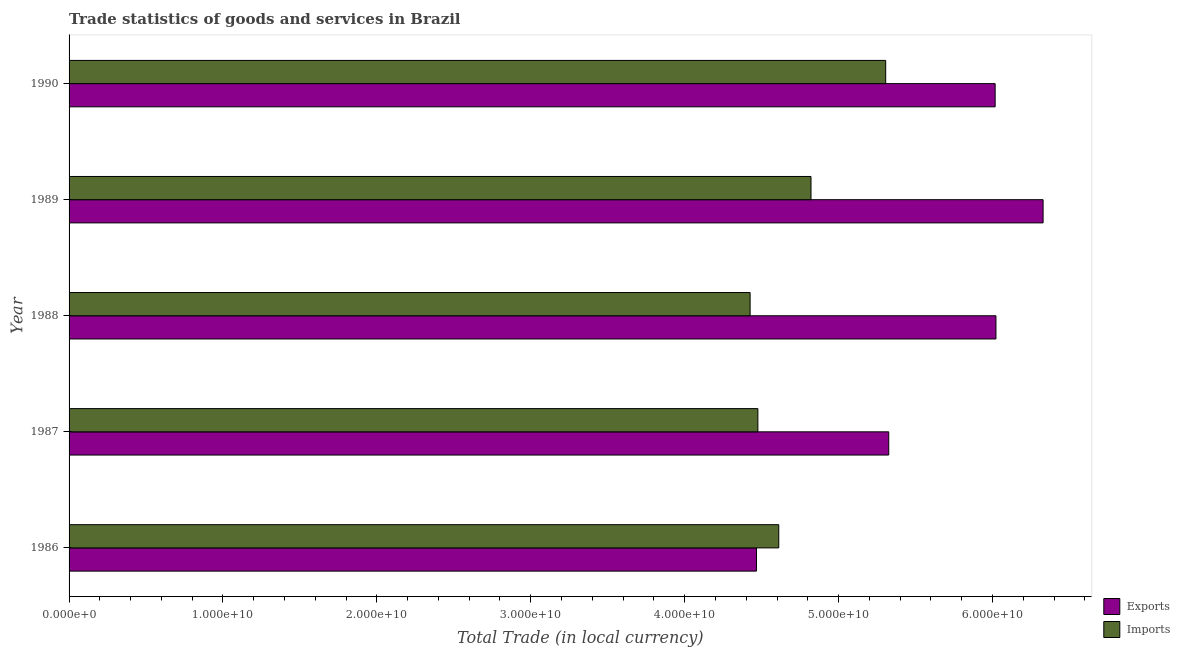How many different coloured bars are there?
Provide a succinct answer. 2. How many groups of bars are there?
Your answer should be very brief. 5. Are the number of bars per tick equal to the number of legend labels?
Provide a succinct answer. Yes. Are the number of bars on each tick of the Y-axis equal?
Give a very brief answer. Yes. What is the label of the 1st group of bars from the top?
Keep it short and to the point. 1990. What is the imports of goods and services in 1989?
Ensure brevity in your answer.  4.82e+1. Across all years, what is the maximum imports of goods and services?
Your response must be concise. 5.31e+1. Across all years, what is the minimum imports of goods and services?
Your answer should be compact. 4.43e+1. In which year was the export of goods and services maximum?
Keep it short and to the point. 1989. What is the total imports of goods and services in the graph?
Provide a short and direct response. 2.36e+11. What is the difference between the imports of goods and services in 1987 and that in 1988?
Provide a short and direct response. 5.04e+08. What is the difference between the imports of goods and services in 1989 and the export of goods and services in 1988?
Provide a short and direct response. -1.20e+1. What is the average imports of goods and services per year?
Ensure brevity in your answer.  4.73e+1. In the year 1987, what is the difference between the export of goods and services and imports of goods and services?
Offer a very short reply. 8.50e+09. In how many years, is the imports of goods and services greater than 48000000000 LCU?
Your answer should be compact. 2. What is the ratio of the imports of goods and services in 1986 to that in 1990?
Your answer should be very brief. 0.87. Is the imports of goods and services in 1986 less than that in 1988?
Keep it short and to the point. No. Is the difference between the imports of goods and services in 1986 and 1990 greater than the difference between the export of goods and services in 1986 and 1990?
Your answer should be very brief. Yes. What is the difference between the highest and the second highest imports of goods and services?
Your answer should be compact. 4.85e+09. What is the difference between the highest and the lowest imports of goods and services?
Your answer should be very brief. 8.81e+09. In how many years, is the export of goods and services greater than the average export of goods and services taken over all years?
Offer a very short reply. 3. Is the sum of the export of goods and services in 1988 and 1989 greater than the maximum imports of goods and services across all years?
Your answer should be compact. Yes. What does the 1st bar from the top in 1988 represents?
Your answer should be compact. Imports. What does the 1st bar from the bottom in 1987 represents?
Give a very brief answer. Exports. Are all the bars in the graph horizontal?
Offer a very short reply. Yes. What is the difference between two consecutive major ticks on the X-axis?
Give a very brief answer. 1.00e+1. Does the graph contain grids?
Provide a short and direct response. No. Where does the legend appear in the graph?
Your response must be concise. Bottom right. How many legend labels are there?
Ensure brevity in your answer.  2. What is the title of the graph?
Give a very brief answer. Trade statistics of goods and services in Brazil. What is the label or title of the X-axis?
Offer a very short reply. Total Trade (in local currency). What is the Total Trade (in local currency) of Exports in 1986?
Keep it short and to the point. 4.47e+1. What is the Total Trade (in local currency) in Imports in 1986?
Provide a succinct answer. 4.61e+1. What is the Total Trade (in local currency) of Exports in 1987?
Provide a succinct answer. 5.33e+1. What is the Total Trade (in local currency) in Imports in 1987?
Give a very brief answer. 4.48e+1. What is the Total Trade (in local currency) of Exports in 1988?
Offer a terse response. 6.02e+1. What is the Total Trade (in local currency) in Imports in 1988?
Your answer should be very brief. 4.43e+1. What is the Total Trade (in local currency) in Exports in 1989?
Your answer should be compact. 6.33e+1. What is the Total Trade (in local currency) of Imports in 1989?
Keep it short and to the point. 4.82e+1. What is the Total Trade (in local currency) in Exports in 1990?
Your answer should be compact. 6.02e+1. What is the Total Trade (in local currency) in Imports in 1990?
Give a very brief answer. 5.31e+1. Across all years, what is the maximum Total Trade (in local currency) of Exports?
Ensure brevity in your answer.  6.33e+1. Across all years, what is the maximum Total Trade (in local currency) of Imports?
Provide a succinct answer. 5.31e+1. Across all years, what is the minimum Total Trade (in local currency) in Exports?
Your answer should be compact. 4.47e+1. Across all years, what is the minimum Total Trade (in local currency) of Imports?
Provide a succinct answer. 4.43e+1. What is the total Total Trade (in local currency) of Exports in the graph?
Offer a terse response. 2.82e+11. What is the total Total Trade (in local currency) of Imports in the graph?
Provide a succinct answer. 2.36e+11. What is the difference between the Total Trade (in local currency) in Exports in 1986 and that in 1987?
Offer a terse response. -8.59e+09. What is the difference between the Total Trade (in local currency) of Imports in 1986 and that in 1987?
Your response must be concise. 1.36e+09. What is the difference between the Total Trade (in local currency) of Exports in 1986 and that in 1988?
Your response must be concise. -1.56e+1. What is the difference between the Total Trade (in local currency) in Imports in 1986 and that in 1988?
Your answer should be compact. 1.86e+09. What is the difference between the Total Trade (in local currency) of Exports in 1986 and that in 1989?
Offer a very short reply. -1.86e+1. What is the difference between the Total Trade (in local currency) in Imports in 1986 and that in 1989?
Make the answer very short. -2.09e+09. What is the difference between the Total Trade (in local currency) in Exports in 1986 and that in 1990?
Give a very brief answer. -1.55e+1. What is the difference between the Total Trade (in local currency) of Imports in 1986 and that in 1990?
Give a very brief answer. -6.95e+09. What is the difference between the Total Trade (in local currency) of Exports in 1987 and that in 1988?
Your response must be concise. -6.97e+09. What is the difference between the Total Trade (in local currency) in Imports in 1987 and that in 1988?
Offer a very short reply. 5.04e+08. What is the difference between the Total Trade (in local currency) of Exports in 1987 and that in 1989?
Your response must be concise. -1.00e+1. What is the difference between the Total Trade (in local currency) in Imports in 1987 and that in 1989?
Offer a terse response. -3.45e+09. What is the difference between the Total Trade (in local currency) of Exports in 1987 and that in 1990?
Provide a succinct answer. -6.91e+09. What is the difference between the Total Trade (in local currency) in Imports in 1987 and that in 1990?
Keep it short and to the point. -8.30e+09. What is the difference between the Total Trade (in local currency) in Exports in 1988 and that in 1989?
Your answer should be compact. -3.06e+09. What is the difference between the Total Trade (in local currency) in Imports in 1988 and that in 1989?
Provide a succinct answer. -3.96e+09. What is the difference between the Total Trade (in local currency) in Exports in 1988 and that in 1990?
Your answer should be very brief. 5.22e+07. What is the difference between the Total Trade (in local currency) in Imports in 1988 and that in 1990?
Give a very brief answer. -8.81e+09. What is the difference between the Total Trade (in local currency) of Exports in 1989 and that in 1990?
Provide a succinct answer. 3.12e+09. What is the difference between the Total Trade (in local currency) of Imports in 1989 and that in 1990?
Your answer should be very brief. -4.85e+09. What is the difference between the Total Trade (in local currency) of Exports in 1986 and the Total Trade (in local currency) of Imports in 1987?
Your answer should be compact. -8.84e+07. What is the difference between the Total Trade (in local currency) in Exports in 1986 and the Total Trade (in local currency) in Imports in 1988?
Ensure brevity in your answer.  4.16e+08. What is the difference between the Total Trade (in local currency) of Exports in 1986 and the Total Trade (in local currency) of Imports in 1989?
Provide a succinct answer. -3.54e+09. What is the difference between the Total Trade (in local currency) of Exports in 1986 and the Total Trade (in local currency) of Imports in 1990?
Ensure brevity in your answer.  -8.39e+09. What is the difference between the Total Trade (in local currency) in Exports in 1987 and the Total Trade (in local currency) in Imports in 1988?
Offer a very short reply. 9.01e+09. What is the difference between the Total Trade (in local currency) in Exports in 1987 and the Total Trade (in local currency) in Imports in 1989?
Ensure brevity in your answer.  5.05e+09. What is the difference between the Total Trade (in local currency) of Exports in 1987 and the Total Trade (in local currency) of Imports in 1990?
Offer a terse response. 1.99e+08. What is the difference between the Total Trade (in local currency) of Exports in 1988 and the Total Trade (in local currency) of Imports in 1989?
Offer a terse response. 1.20e+1. What is the difference between the Total Trade (in local currency) in Exports in 1988 and the Total Trade (in local currency) in Imports in 1990?
Ensure brevity in your answer.  7.17e+09. What is the difference between the Total Trade (in local currency) of Exports in 1989 and the Total Trade (in local currency) of Imports in 1990?
Provide a short and direct response. 1.02e+1. What is the average Total Trade (in local currency) in Exports per year?
Keep it short and to the point. 5.63e+1. What is the average Total Trade (in local currency) of Imports per year?
Your response must be concise. 4.73e+1. In the year 1986, what is the difference between the Total Trade (in local currency) of Exports and Total Trade (in local currency) of Imports?
Your response must be concise. -1.45e+09. In the year 1987, what is the difference between the Total Trade (in local currency) of Exports and Total Trade (in local currency) of Imports?
Offer a terse response. 8.50e+09. In the year 1988, what is the difference between the Total Trade (in local currency) of Exports and Total Trade (in local currency) of Imports?
Make the answer very short. 1.60e+1. In the year 1989, what is the difference between the Total Trade (in local currency) of Exports and Total Trade (in local currency) of Imports?
Offer a terse response. 1.51e+1. In the year 1990, what is the difference between the Total Trade (in local currency) in Exports and Total Trade (in local currency) in Imports?
Offer a very short reply. 7.11e+09. What is the ratio of the Total Trade (in local currency) of Exports in 1986 to that in 1987?
Your answer should be compact. 0.84. What is the ratio of the Total Trade (in local currency) of Imports in 1986 to that in 1987?
Make the answer very short. 1.03. What is the ratio of the Total Trade (in local currency) in Exports in 1986 to that in 1988?
Make the answer very short. 0.74. What is the ratio of the Total Trade (in local currency) of Imports in 1986 to that in 1988?
Offer a terse response. 1.04. What is the ratio of the Total Trade (in local currency) in Exports in 1986 to that in 1989?
Provide a short and direct response. 0.71. What is the ratio of the Total Trade (in local currency) in Imports in 1986 to that in 1989?
Your answer should be compact. 0.96. What is the ratio of the Total Trade (in local currency) of Exports in 1986 to that in 1990?
Make the answer very short. 0.74. What is the ratio of the Total Trade (in local currency) of Imports in 1986 to that in 1990?
Your answer should be very brief. 0.87. What is the ratio of the Total Trade (in local currency) of Exports in 1987 to that in 1988?
Make the answer very short. 0.88. What is the ratio of the Total Trade (in local currency) of Imports in 1987 to that in 1988?
Offer a terse response. 1.01. What is the ratio of the Total Trade (in local currency) in Exports in 1987 to that in 1989?
Give a very brief answer. 0.84. What is the ratio of the Total Trade (in local currency) in Imports in 1987 to that in 1989?
Make the answer very short. 0.93. What is the ratio of the Total Trade (in local currency) of Exports in 1987 to that in 1990?
Your answer should be very brief. 0.89. What is the ratio of the Total Trade (in local currency) in Imports in 1987 to that in 1990?
Make the answer very short. 0.84. What is the ratio of the Total Trade (in local currency) of Exports in 1988 to that in 1989?
Give a very brief answer. 0.95. What is the ratio of the Total Trade (in local currency) of Imports in 1988 to that in 1989?
Your answer should be very brief. 0.92. What is the ratio of the Total Trade (in local currency) of Exports in 1988 to that in 1990?
Make the answer very short. 1. What is the ratio of the Total Trade (in local currency) of Imports in 1988 to that in 1990?
Give a very brief answer. 0.83. What is the ratio of the Total Trade (in local currency) of Exports in 1989 to that in 1990?
Your response must be concise. 1.05. What is the ratio of the Total Trade (in local currency) of Imports in 1989 to that in 1990?
Keep it short and to the point. 0.91. What is the difference between the highest and the second highest Total Trade (in local currency) in Exports?
Give a very brief answer. 3.06e+09. What is the difference between the highest and the second highest Total Trade (in local currency) in Imports?
Keep it short and to the point. 4.85e+09. What is the difference between the highest and the lowest Total Trade (in local currency) in Exports?
Provide a short and direct response. 1.86e+1. What is the difference between the highest and the lowest Total Trade (in local currency) of Imports?
Make the answer very short. 8.81e+09. 